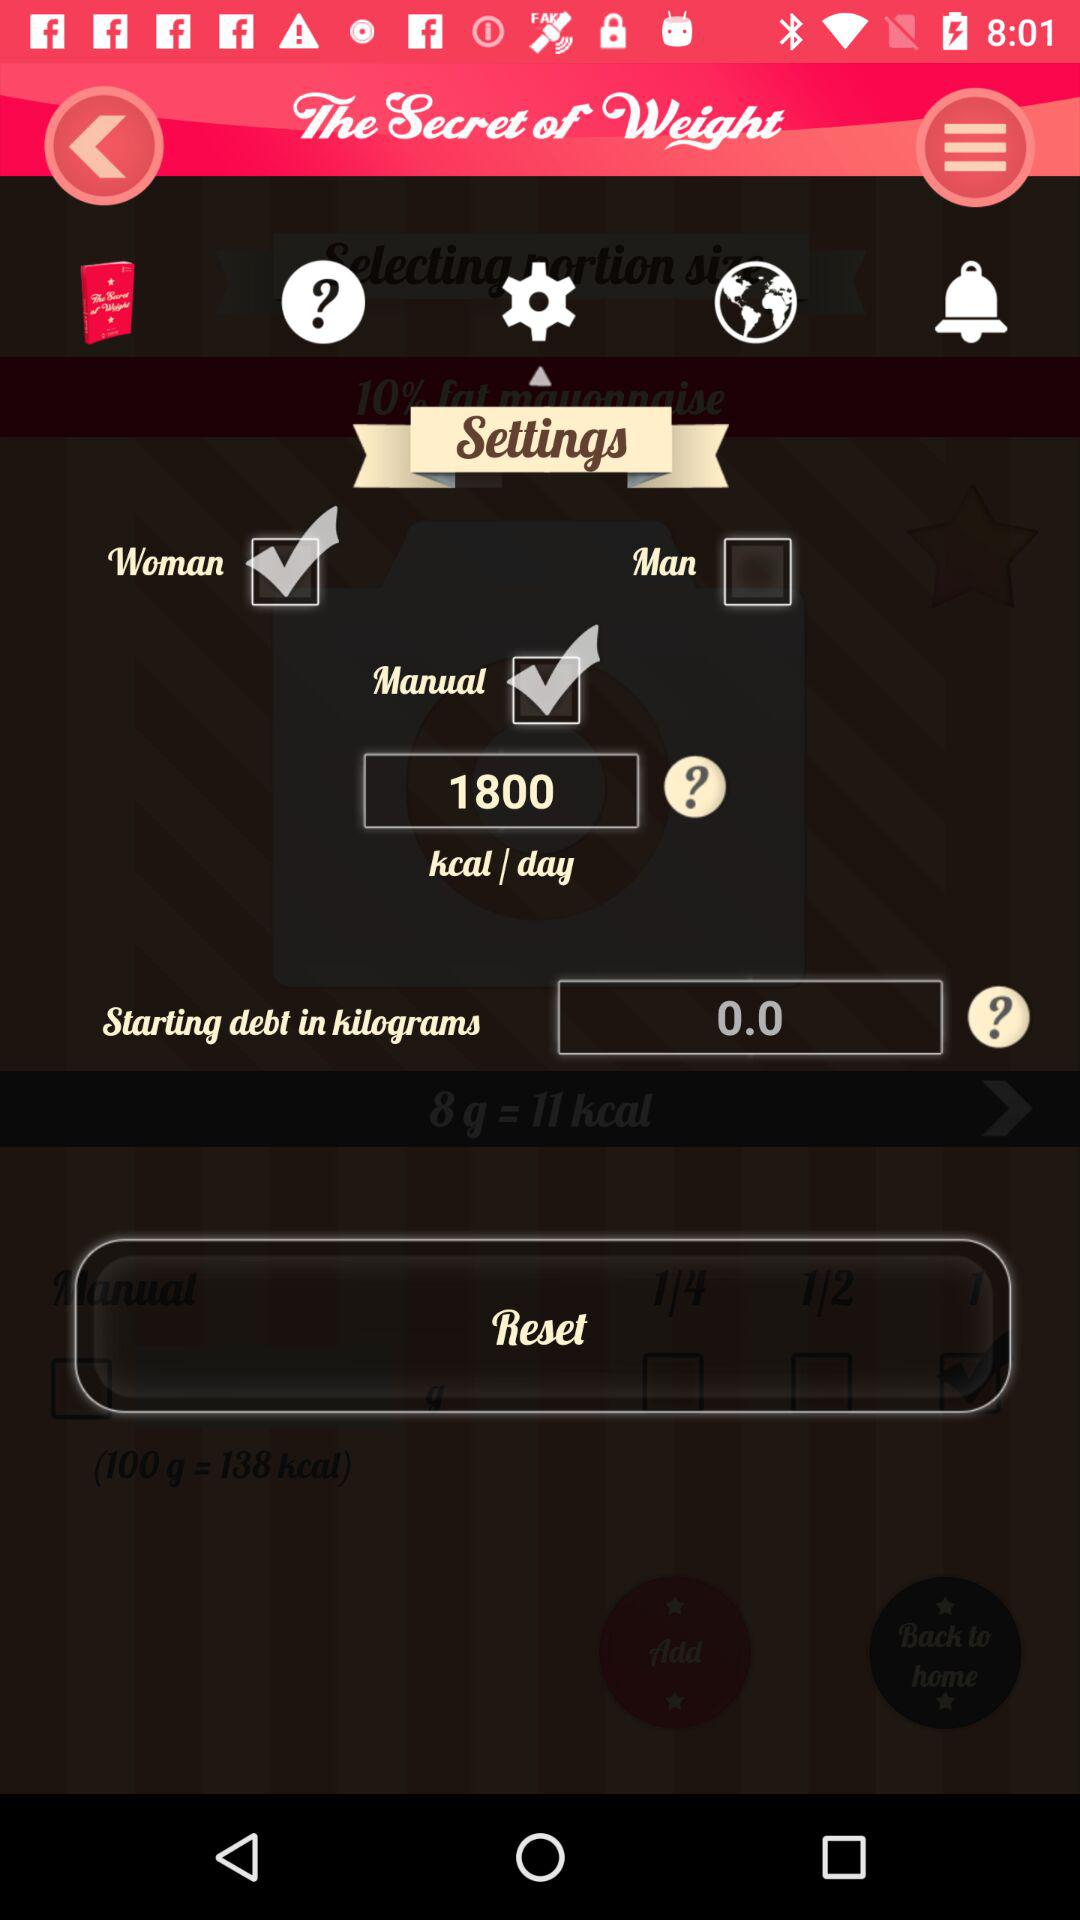What is the starting debt in kilograms? The starting debt in kilograms is 0. 